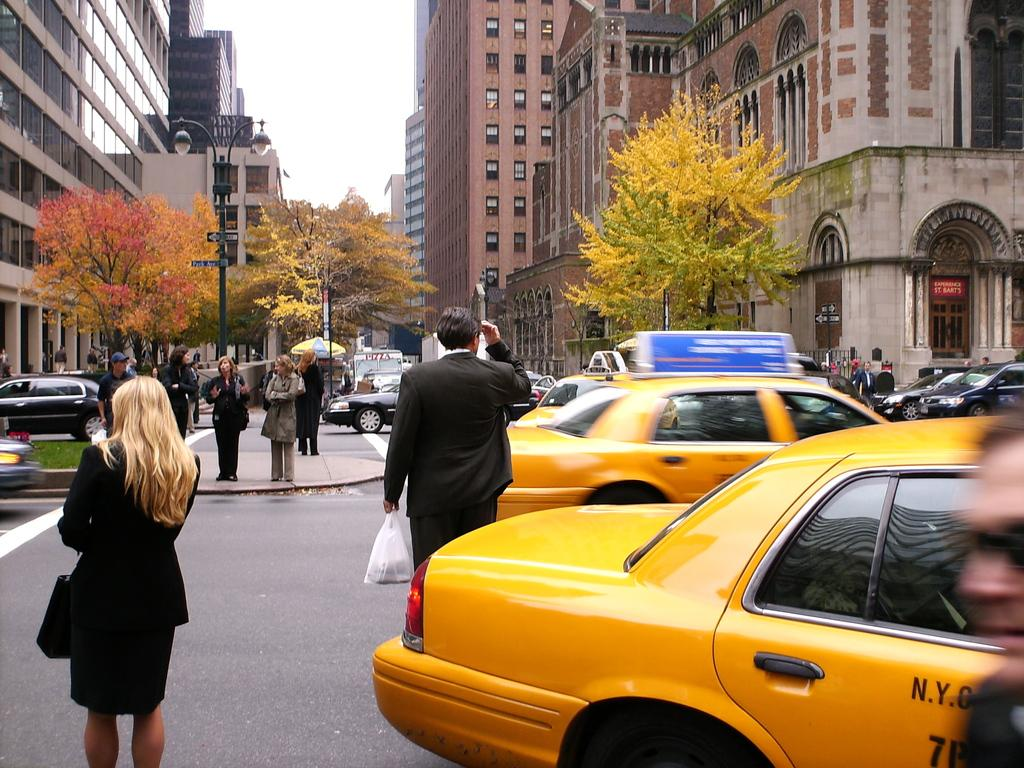Provide a one-sentence caption for the provided image. a lady next to a taxi with the letter N on it. 